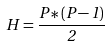<formula> <loc_0><loc_0><loc_500><loc_500>H = \frac { P * ( P - 1 ) } { 2 }</formula> 